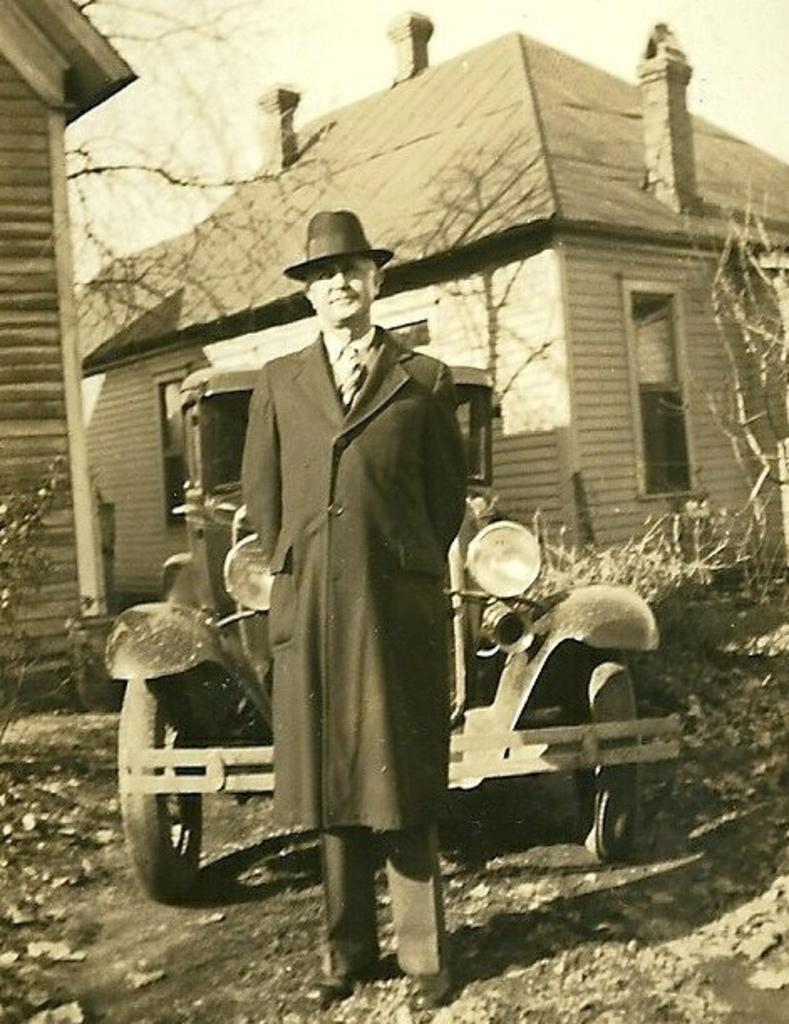What is the main subject of the image? There is a man standing in the image. Can you describe the man's attire? The man is wearing a hat. What is the man's proximity to a vehicle? The man is near a vehicle. What can be seen in the background of the image? There are houses and dried plants in the background of the image. What type of hook can be seen hanging from the man's foot in the image? There is no hook present on the man's foot in the image. 